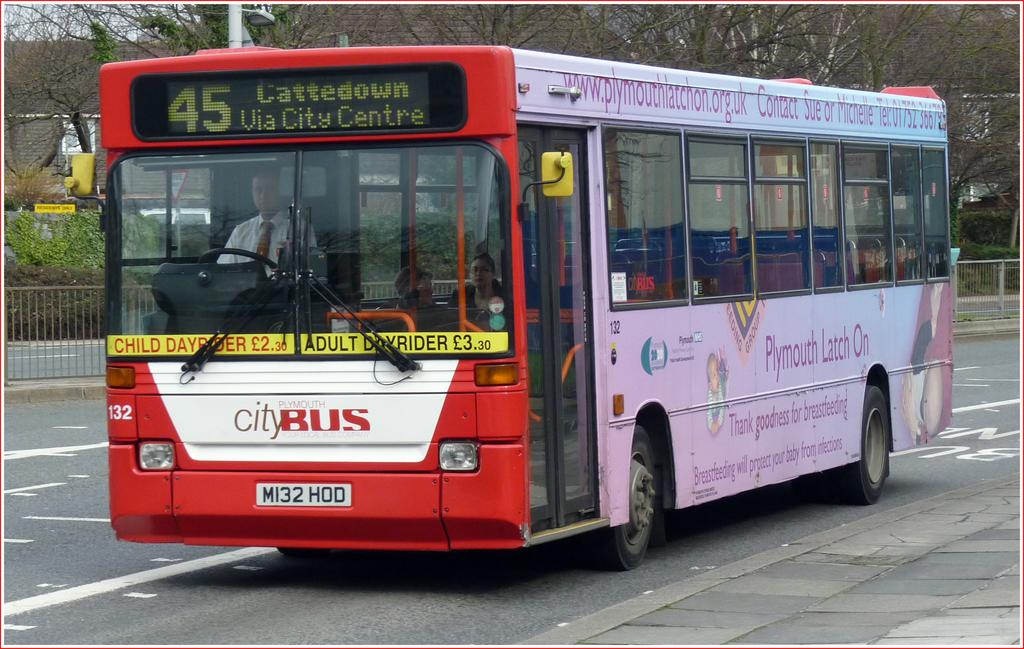<image>
Provide a brief description of the given image. City bus driving on the road colored red, white and pink. 